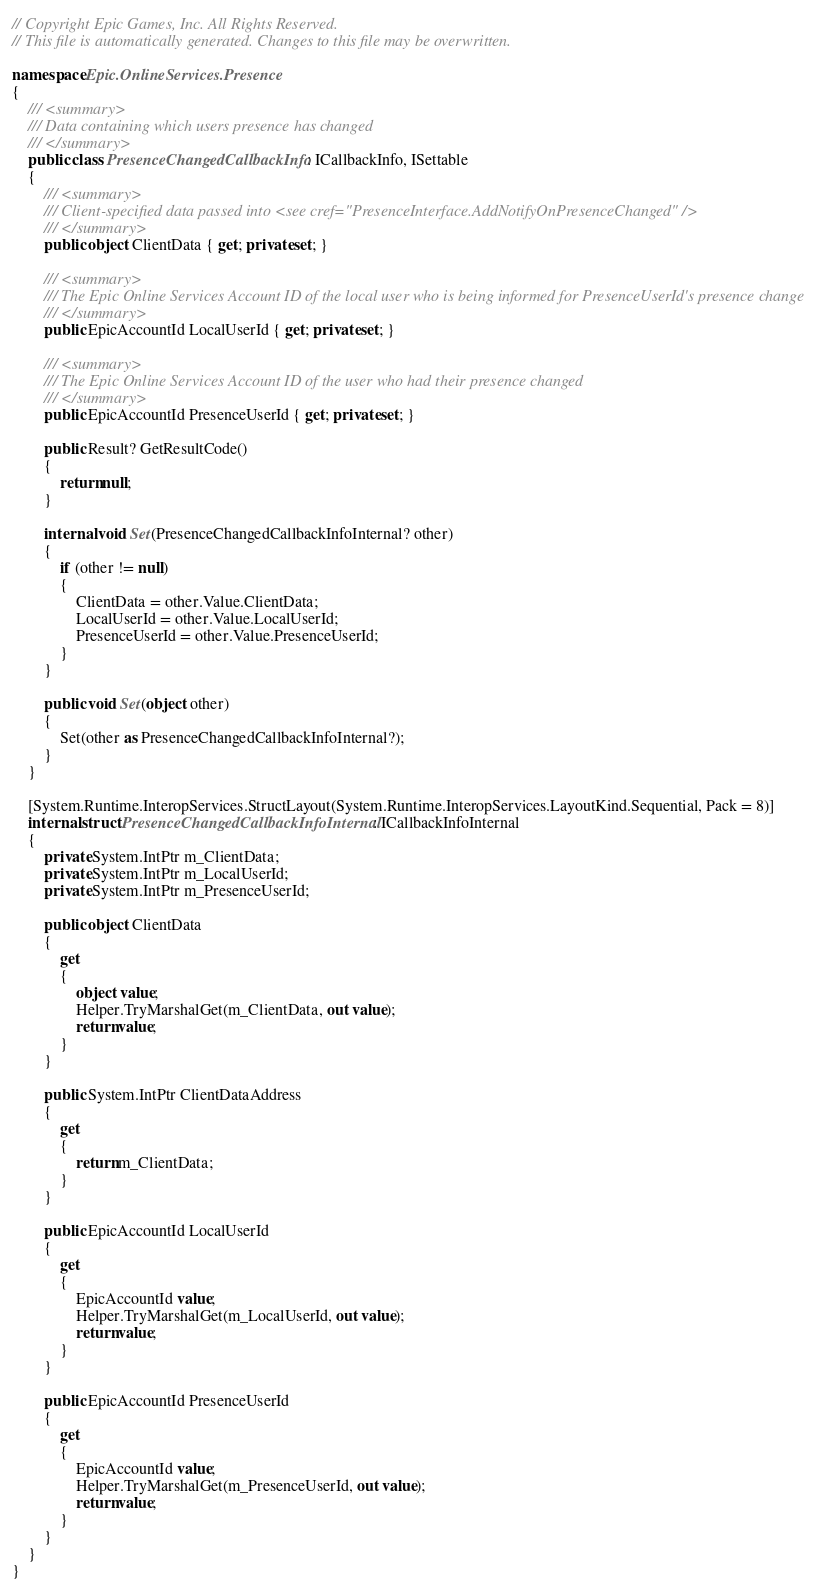<code> <loc_0><loc_0><loc_500><loc_500><_C#_>// Copyright Epic Games, Inc. All Rights Reserved.
// This file is automatically generated. Changes to this file may be overwritten.

namespace Epic.OnlineServices.Presence
{
	/// <summary>
	/// Data containing which users presence has changed
	/// </summary>
	public class PresenceChangedCallbackInfo : ICallbackInfo, ISettable
	{
		/// <summary>
		/// Client-specified data passed into <see cref="PresenceInterface.AddNotifyOnPresenceChanged" />
		/// </summary>
		public object ClientData { get; private set; }

		/// <summary>
		/// The Epic Online Services Account ID of the local user who is being informed for PresenceUserId's presence change
		/// </summary>
		public EpicAccountId LocalUserId { get; private set; }

		/// <summary>
		/// The Epic Online Services Account ID of the user who had their presence changed
		/// </summary>
		public EpicAccountId PresenceUserId { get; private set; }

		public Result? GetResultCode()
		{
			return null;
		}

		internal void Set(PresenceChangedCallbackInfoInternal? other)
		{
			if (other != null)
			{
				ClientData = other.Value.ClientData;
				LocalUserId = other.Value.LocalUserId;
				PresenceUserId = other.Value.PresenceUserId;
			}
		}

		public void Set(object other)
		{
			Set(other as PresenceChangedCallbackInfoInternal?);
		}
	}

	[System.Runtime.InteropServices.StructLayout(System.Runtime.InteropServices.LayoutKind.Sequential, Pack = 8)]
	internal struct PresenceChangedCallbackInfoInternal : ICallbackInfoInternal
	{
		private System.IntPtr m_ClientData;
		private System.IntPtr m_LocalUserId;
		private System.IntPtr m_PresenceUserId;

		public object ClientData
		{
			get
			{
				object value;
				Helper.TryMarshalGet(m_ClientData, out value);
				return value;
			}
		}

		public System.IntPtr ClientDataAddress
		{
			get
			{
				return m_ClientData;
			}
		}

		public EpicAccountId LocalUserId
		{
			get
			{
				EpicAccountId value;
				Helper.TryMarshalGet(m_LocalUserId, out value);
				return value;
			}
		}

		public EpicAccountId PresenceUserId
		{
			get
			{
				EpicAccountId value;
				Helper.TryMarshalGet(m_PresenceUserId, out value);
				return value;
			}
		}
	}
}</code> 